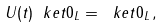<formula> <loc_0><loc_0><loc_500><loc_500>U ( t ) \ k e t { 0 } _ { L } = \ k e t { 0 } _ { L } \, ,</formula> 